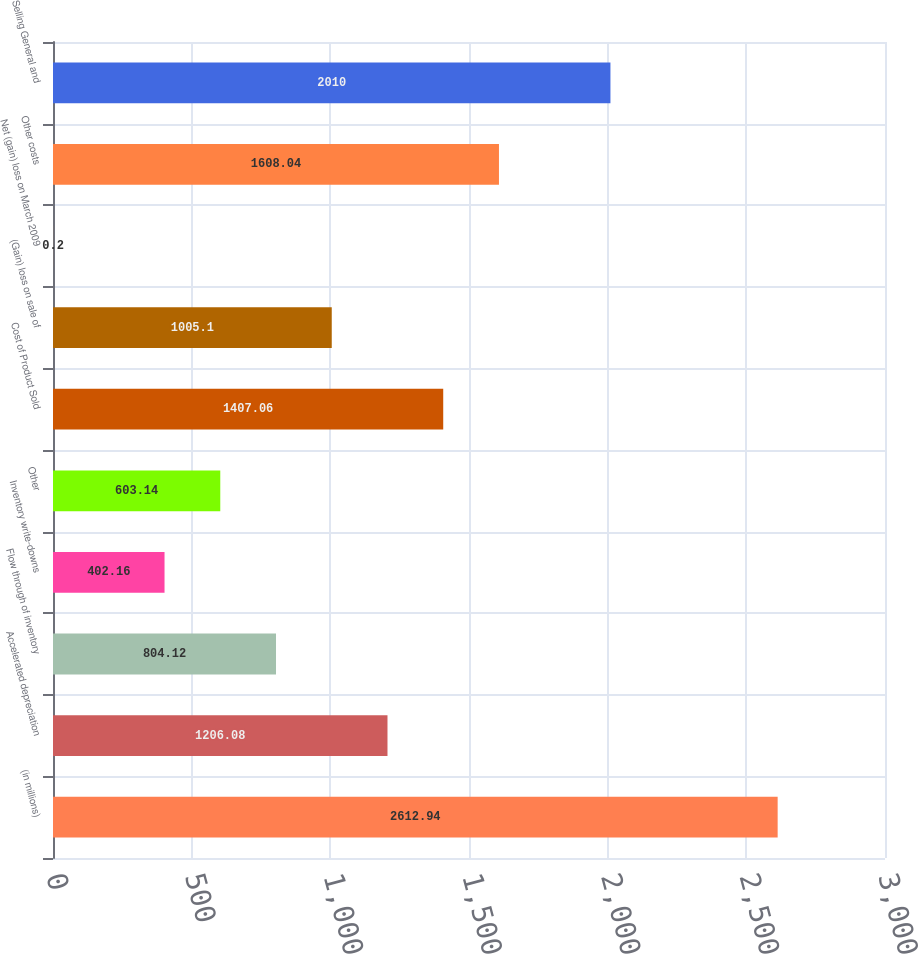<chart> <loc_0><loc_0><loc_500><loc_500><bar_chart><fcel>(in millions)<fcel>Accelerated depreciation<fcel>Flow through of inventory<fcel>Inventory write-downs<fcel>Other<fcel>Cost of Product Sold<fcel>(Gain) loss on sale of<fcel>Net (gain) loss on March 2009<fcel>Other costs<fcel>Selling General and<nl><fcel>2612.94<fcel>1206.08<fcel>804.12<fcel>402.16<fcel>603.14<fcel>1407.06<fcel>1005.1<fcel>0.2<fcel>1608.04<fcel>2010<nl></chart> 